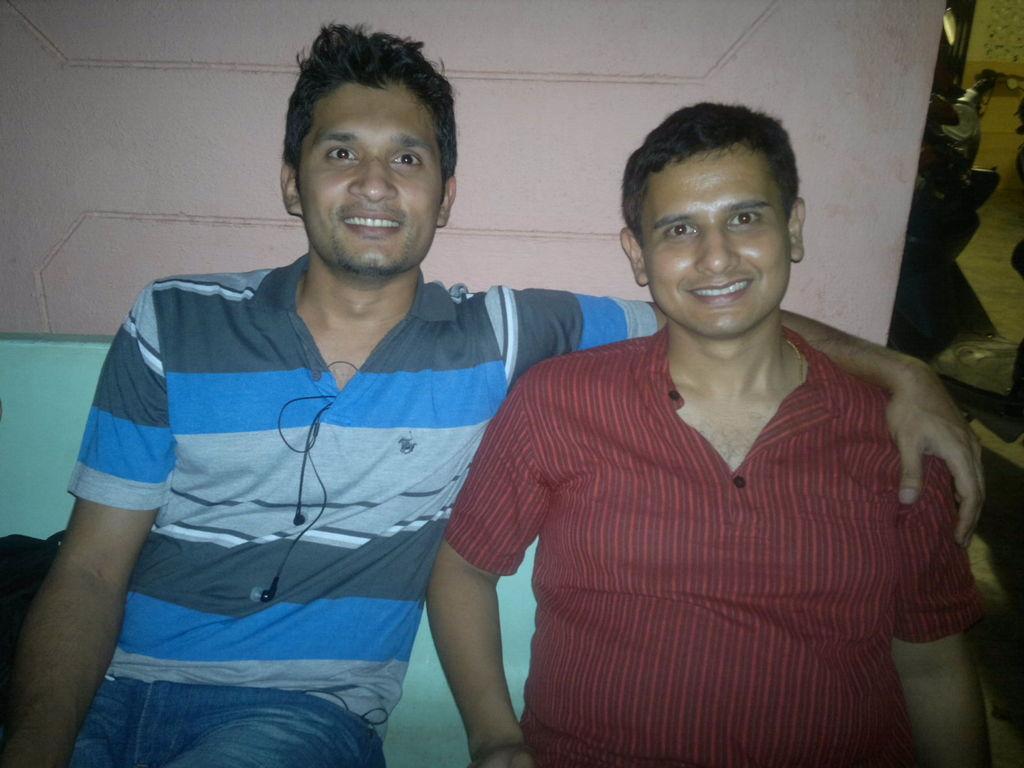Please provide a concise description of this image. In this image there are two men sitting. They are smiling. Behind them there is the wall. To the right there are a few objects in the image. 